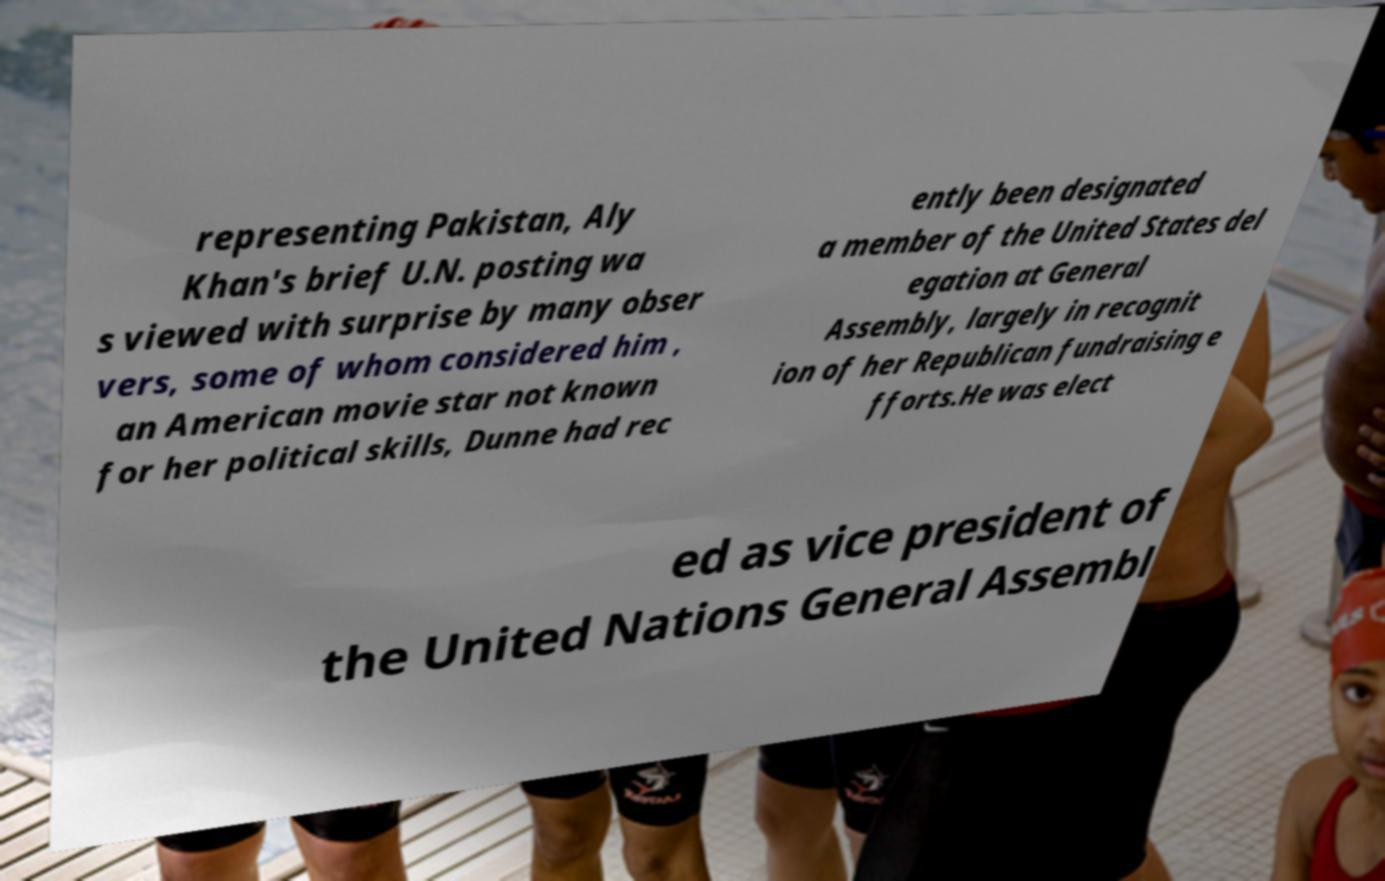I need the written content from this picture converted into text. Can you do that? representing Pakistan, Aly Khan's brief U.N. posting wa s viewed with surprise by many obser vers, some of whom considered him , an American movie star not known for her political skills, Dunne had rec ently been designated a member of the United States del egation at General Assembly, largely in recognit ion of her Republican fundraising e fforts.He was elect ed as vice president of the United Nations General Assembl 